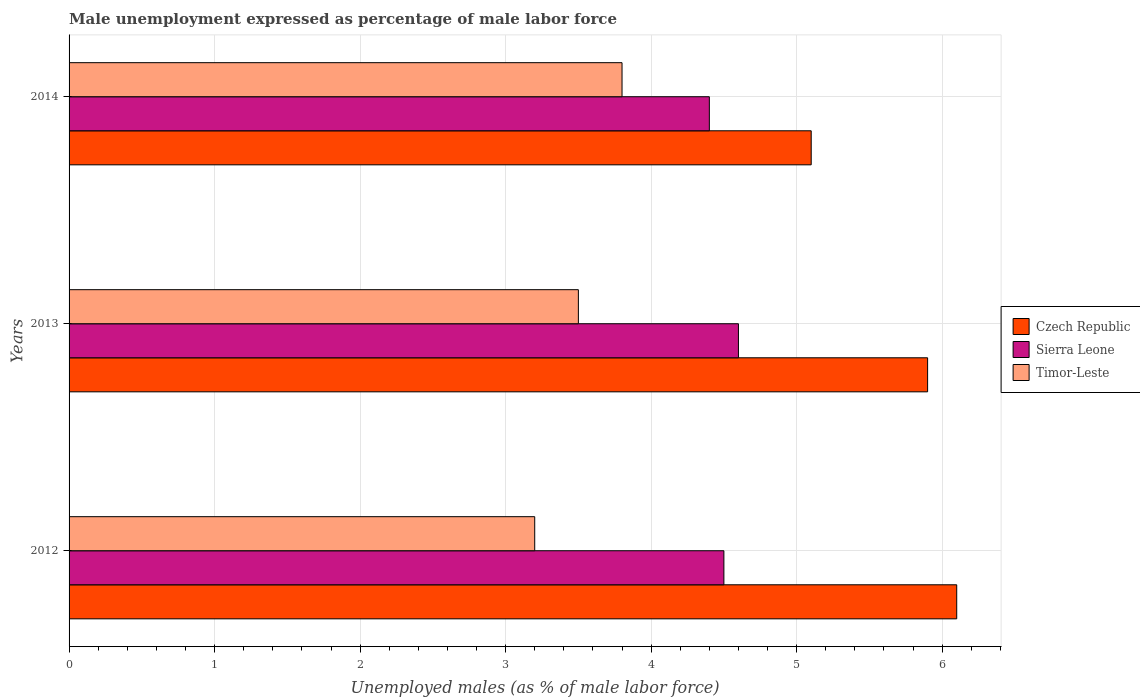How many bars are there on the 3rd tick from the top?
Keep it short and to the point. 3. In how many cases, is the number of bars for a given year not equal to the number of legend labels?
Your response must be concise. 0. What is the unemployment in males in in Czech Republic in 2014?
Give a very brief answer. 5.1. Across all years, what is the maximum unemployment in males in in Sierra Leone?
Offer a very short reply. 4.6. Across all years, what is the minimum unemployment in males in in Sierra Leone?
Provide a succinct answer. 4.4. In which year was the unemployment in males in in Sierra Leone maximum?
Provide a succinct answer. 2013. What is the total unemployment in males in in Czech Republic in the graph?
Your answer should be very brief. 17.1. What is the difference between the unemployment in males in in Czech Republic in 2012 and that in 2014?
Your answer should be compact. 1. What is the difference between the unemployment in males in in Sierra Leone in 2013 and the unemployment in males in in Czech Republic in 2012?
Your response must be concise. -1.5. What is the average unemployment in males in in Timor-Leste per year?
Your answer should be very brief. 3.5. In the year 2013, what is the difference between the unemployment in males in in Sierra Leone and unemployment in males in in Czech Republic?
Your answer should be very brief. -1.3. In how many years, is the unemployment in males in in Sierra Leone greater than 4.2 %?
Provide a succinct answer. 3. What is the ratio of the unemployment in males in in Sierra Leone in 2012 to that in 2014?
Give a very brief answer. 1.02. Is the difference between the unemployment in males in in Sierra Leone in 2012 and 2013 greater than the difference between the unemployment in males in in Czech Republic in 2012 and 2013?
Your answer should be compact. No. What is the difference between the highest and the second highest unemployment in males in in Sierra Leone?
Offer a terse response. 0.1. What is the difference between the highest and the lowest unemployment in males in in Czech Republic?
Keep it short and to the point. 1. Is the sum of the unemployment in males in in Czech Republic in 2012 and 2014 greater than the maximum unemployment in males in in Sierra Leone across all years?
Provide a short and direct response. Yes. What does the 1st bar from the top in 2012 represents?
Give a very brief answer. Timor-Leste. What does the 3rd bar from the bottom in 2014 represents?
Keep it short and to the point. Timor-Leste. How many bars are there?
Give a very brief answer. 9. Are all the bars in the graph horizontal?
Provide a succinct answer. Yes. Are the values on the major ticks of X-axis written in scientific E-notation?
Your answer should be very brief. No. Does the graph contain any zero values?
Give a very brief answer. No. Does the graph contain grids?
Give a very brief answer. Yes. How many legend labels are there?
Ensure brevity in your answer.  3. How are the legend labels stacked?
Your response must be concise. Vertical. What is the title of the graph?
Offer a terse response. Male unemployment expressed as percentage of male labor force. What is the label or title of the X-axis?
Ensure brevity in your answer.  Unemployed males (as % of male labor force). What is the label or title of the Y-axis?
Provide a short and direct response. Years. What is the Unemployed males (as % of male labor force) in Czech Republic in 2012?
Give a very brief answer. 6.1. What is the Unemployed males (as % of male labor force) in Timor-Leste in 2012?
Ensure brevity in your answer.  3.2. What is the Unemployed males (as % of male labor force) of Czech Republic in 2013?
Provide a short and direct response. 5.9. What is the Unemployed males (as % of male labor force) of Sierra Leone in 2013?
Provide a succinct answer. 4.6. What is the Unemployed males (as % of male labor force) of Czech Republic in 2014?
Your answer should be very brief. 5.1. What is the Unemployed males (as % of male labor force) in Sierra Leone in 2014?
Provide a short and direct response. 4.4. What is the Unemployed males (as % of male labor force) in Timor-Leste in 2014?
Your answer should be compact. 3.8. Across all years, what is the maximum Unemployed males (as % of male labor force) of Czech Republic?
Make the answer very short. 6.1. Across all years, what is the maximum Unemployed males (as % of male labor force) in Sierra Leone?
Offer a very short reply. 4.6. Across all years, what is the maximum Unemployed males (as % of male labor force) of Timor-Leste?
Provide a succinct answer. 3.8. Across all years, what is the minimum Unemployed males (as % of male labor force) in Czech Republic?
Provide a short and direct response. 5.1. Across all years, what is the minimum Unemployed males (as % of male labor force) of Sierra Leone?
Offer a very short reply. 4.4. Across all years, what is the minimum Unemployed males (as % of male labor force) in Timor-Leste?
Provide a short and direct response. 3.2. What is the total Unemployed males (as % of male labor force) of Czech Republic in the graph?
Offer a very short reply. 17.1. What is the total Unemployed males (as % of male labor force) in Sierra Leone in the graph?
Provide a succinct answer. 13.5. What is the difference between the Unemployed males (as % of male labor force) in Czech Republic in 2012 and that in 2013?
Provide a short and direct response. 0.2. What is the difference between the Unemployed males (as % of male labor force) in Sierra Leone in 2012 and that in 2013?
Your answer should be very brief. -0.1. What is the difference between the Unemployed males (as % of male labor force) in Czech Republic in 2012 and that in 2014?
Provide a succinct answer. 1. What is the difference between the Unemployed males (as % of male labor force) in Czech Republic in 2013 and that in 2014?
Make the answer very short. 0.8. What is the difference between the Unemployed males (as % of male labor force) in Sierra Leone in 2013 and that in 2014?
Give a very brief answer. 0.2. What is the difference between the Unemployed males (as % of male labor force) of Sierra Leone in 2012 and the Unemployed males (as % of male labor force) of Timor-Leste in 2013?
Give a very brief answer. 1. What is the difference between the Unemployed males (as % of male labor force) in Czech Republic in 2012 and the Unemployed males (as % of male labor force) in Timor-Leste in 2014?
Offer a very short reply. 2.3. What is the difference between the Unemployed males (as % of male labor force) in Sierra Leone in 2012 and the Unemployed males (as % of male labor force) in Timor-Leste in 2014?
Your answer should be compact. 0.7. What is the difference between the Unemployed males (as % of male labor force) of Czech Republic in 2013 and the Unemployed males (as % of male labor force) of Sierra Leone in 2014?
Make the answer very short. 1.5. What is the average Unemployed males (as % of male labor force) in Czech Republic per year?
Provide a short and direct response. 5.7. What is the average Unemployed males (as % of male labor force) in Timor-Leste per year?
Provide a succinct answer. 3.5. In the year 2012, what is the difference between the Unemployed males (as % of male labor force) of Czech Republic and Unemployed males (as % of male labor force) of Sierra Leone?
Your answer should be very brief. 1.6. In the year 2014, what is the difference between the Unemployed males (as % of male labor force) in Czech Republic and Unemployed males (as % of male labor force) in Sierra Leone?
Your answer should be very brief. 0.7. In the year 2014, what is the difference between the Unemployed males (as % of male labor force) of Czech Republic and Unemployed males (as % of male labor force) of Timor-Leste?
Ensure brevity in your answer.  1.3. In the year 2014, what is the difference between the Unemployed males (as % of male labor force) in Sierra Leone and Unemployed males (as % of male labor force) in Timor-Leste?
Your answer should be very brief. 0.6. What is the ratio of the Unemployed males (as % of male labor force) in Czech Republic in 2012 to that in 2013?
Ensure brevity in your answer.  1.03. What is the ratio of the Unemployed males (as % of male labor force) in Sierra Leone in 2012 to that in 2013?
Your answer should be very brief. 0.98. What is the ratio of the Unemployed males (as % of male labor force) of Timor-Leste in 2012 to that in 2013?
Ensure brevity in your answer.  0.91. What is the ratio of the Unemployed males (as % of male labor force) in Czech Republic in 2012 to that in 2014?
Provide a short and direct response. 1.2. What is the ratio of the Unemployed males (as % of male labor force) of Sierra Leone in 2012 to that in 2014?
Ensure brevity in your answer.  1.02. What is the ratio of the Unemployed males (as % of male labor force) in Timor-Leste in 2012 to that in 2014?
Make the answer very short. 0.84. What is the ratio of the Unemployed males (as % of male labor force) of Czech Republic in 2013 to that in 2014?
Offer a very short reply. 1.16. What is the ratio of the Unemployed males (as % of male labor force) of Sierra Leone in 2013 to that in 2014?
Your answer should be compact. 1.05. What is the ratio of the Unemployed males (as % of male labor force) of Timor-Leste in 2013 to that in 2014?
Ensure brevity in your answer.  0.92. What is the difference between the highest and the second highest Unemployed males (as % of male labor force) of Sierra Leone?
Ensure brevity in your answer.  0.1. What is the difference between the highest and the second highest Unemployed males (as % of male labor force) of Timor-Leste?
Provide a succinct answer. 0.3. What is the difference between the highest and the lowest Unemployed males (as % of male labor force) in Czech Republic?
Make the answer very short. 1. 